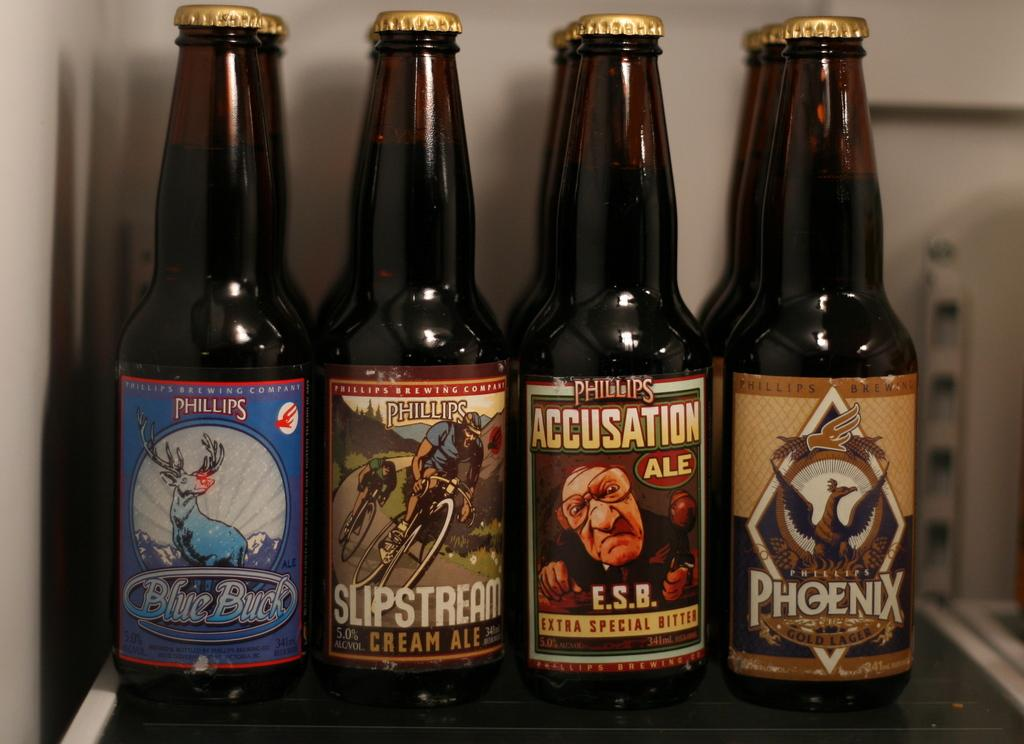<image>
Describe the image concisely. 4 bottles of beer that are together: Blue Buck, Slipstream, Phillips Accusation, and Phoenix. 